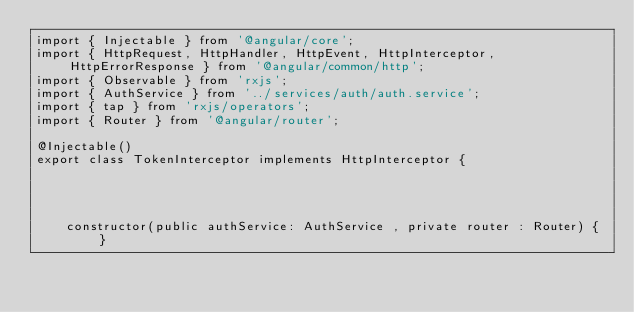Convert code to text. <code><loc_0><loc_0><loc_500><loc_500><_TypeScript_>import { Injectable } from '@angular/core';
import { HttpRequest, HttpHandler, HttpEvent, HttpInterceptor, HttpErrorResponse } from '@angular/common/http';
import { Observable } from 'rxjs';
import { AuthService } from '../services/auth/auth.service';
import { tap } from 'rxjs/operators';
import { Router } from '@angular/router';

@Injectable()
export class TokenInterceptor implements HttpInterceptor {


    

    constructor(public authService: AuthService , private router : Router) { }</code> 